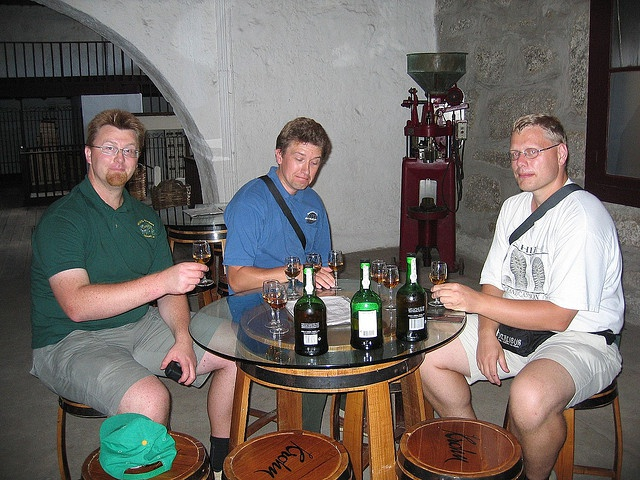Describe the objects in this image and their specific colors. I can see people in black, teal, lightpink, gray, and darkgray tones, people in black, white, lightpink, darkgray, and gray tones, dining table in black, gray, darkgray, and maroon tones, people in black, gray, blue, and lightpink tones, and chair in black, maroon, and brown tones in this image. 